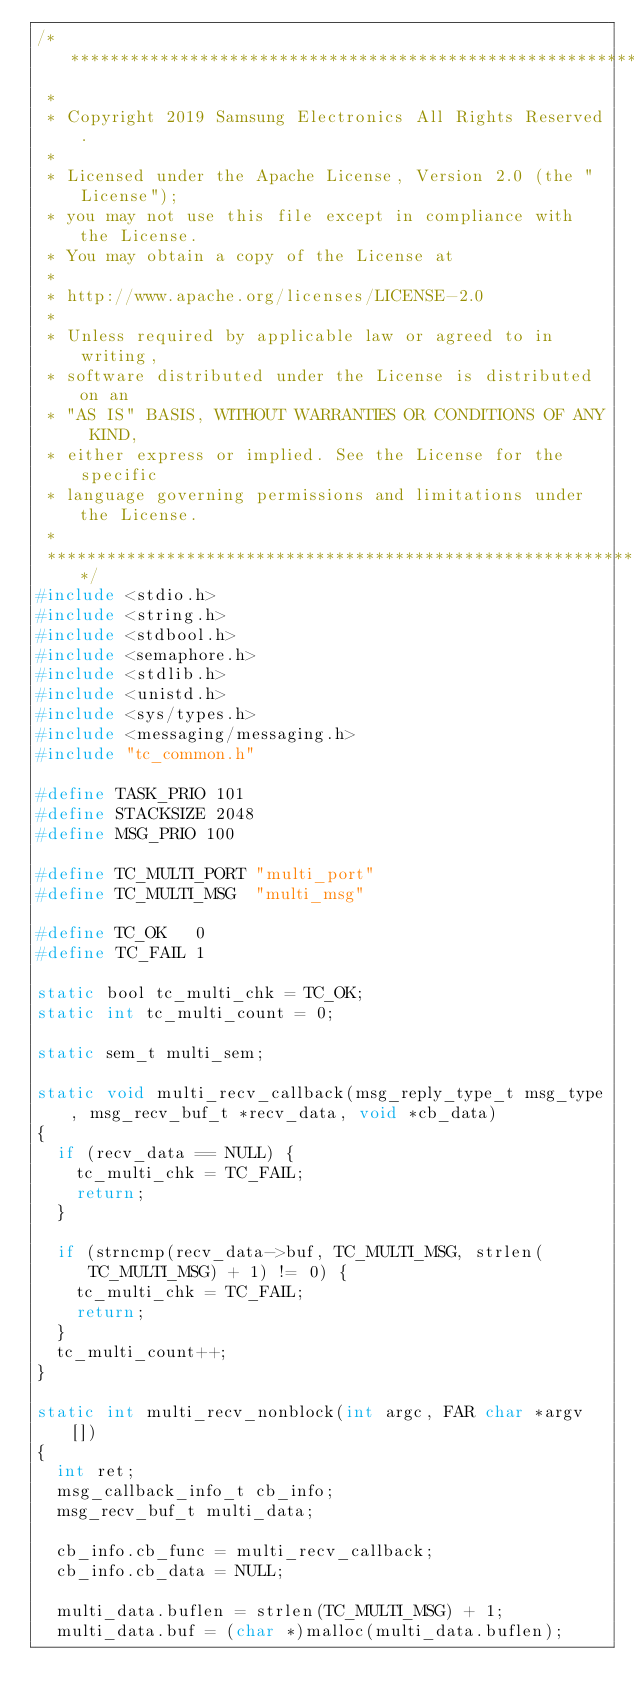<code> <loc_0><loc_0><loc_500><loc_500><_C_>/****************************************************************************
 *
 * Copyright 2019 Samsung Electronics All Rights Reserved.
 *
 * Licensed under the Apache License, Version 2.0 (the "License");
 * you may not use this file except in compliance with the License.
 * You may obtain a copy of the License at
 *
 * http://www.apache.org/licenses/LICENSE-2.0
 *
 * Unless required by applicable law or agreed to in writing,
 * software distributed under the License is distributed on an
 * "AS IS" BASIS, WITHOUT WARRANTIES OR CONDITIONS OF ANY KIND,
 * either express or implied. See the License for the specific
 * language governing permissions and limitations under the License.
 *
 ****************************************************************************/
#include <stdio.h>
#include <string.h>
#include <stdbool.h>
#include <semaphore.h>
#include <stdlib.h>
#include <unistd.h>
#include <sys/types.h>
#include <messaging/messaging.h>
#include "tc_common.h"

#define TASK_PRIO 101
#define STACKSIZE 2048
#define MSG_PRIO 100

#define TC_MULTI_PORT "multi_port"
#define TC_MULTI_MSG  "multi_msg"

#define TC_OK   0
#define TC_FAIL 1

static bool tc_multi_chk = TC_OK;
static int tc_multi_count = 0;

static sem_t multi_sem;

static void multi_recv_callback(msg_reply_type_t msg_type, msg_recv_buf_t *recv_data, void *cb_data)
{
	if (recv_data == NULL) {
		tc_multi_chk = TC_FAIL;
		return;
	}

	if (strncmp(recv_data->buf, TC_MULTI_MSG, strlen(TC_MULTI_MSG) + 1) != 0) {
		tc_multi_chk = TC_FAIL;
		return;
	}
	tc_multi_count++;
}

static int multi_recv_nonblock(int argc, FAR char *argv[])
{
	int ret;
	msg_callback_info_t cb_info;
	msg_recv_buf_t multi_data;

	cb_info.cb_func = multi_recv_callback;
	cb_info.cb_data = NULL;

	multi_data.buflen = strlen(TC_MULTI_MSG) + 1;
	multi_data.buf = (char *)malloc(multi_data.buflen);</code> 